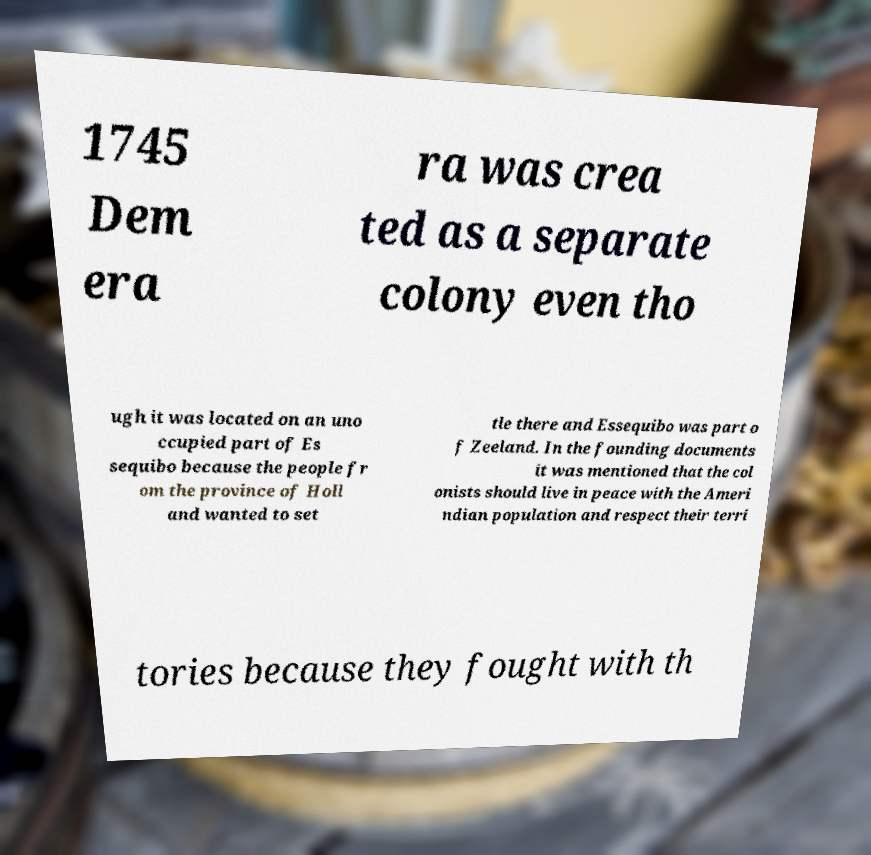Can you accurately transcribe the text from the provided image for me? 1745 Dem era ra was crea ted as a separate colony even tho ugh it was located on an uno ccupied part of Es sequibo because the people fr om the province of Holl and wanted to set tle there and Essequibo was part o f Zeeland. In the founding documents it was mentioned that the col onists should live in peace with the Ameri ndian population and respect their terri tories because they fought with th 